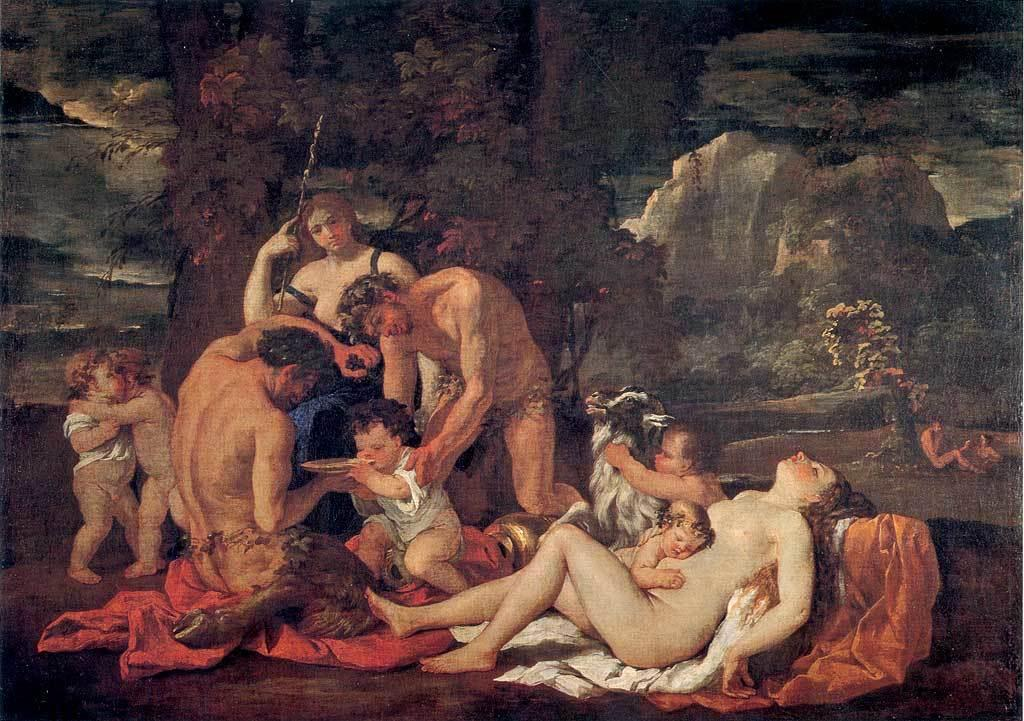What type of artwork is depicted in the image? The image is a painting. What subjects are featured in the painting? There are people and trees in the painting. How would you describe the overall color scheme of the painting? The background of the painting is dark. How many letters can be seen in the painting? There are no letters present in the painting; it is a visual artwork and not a written or text-based piece. 